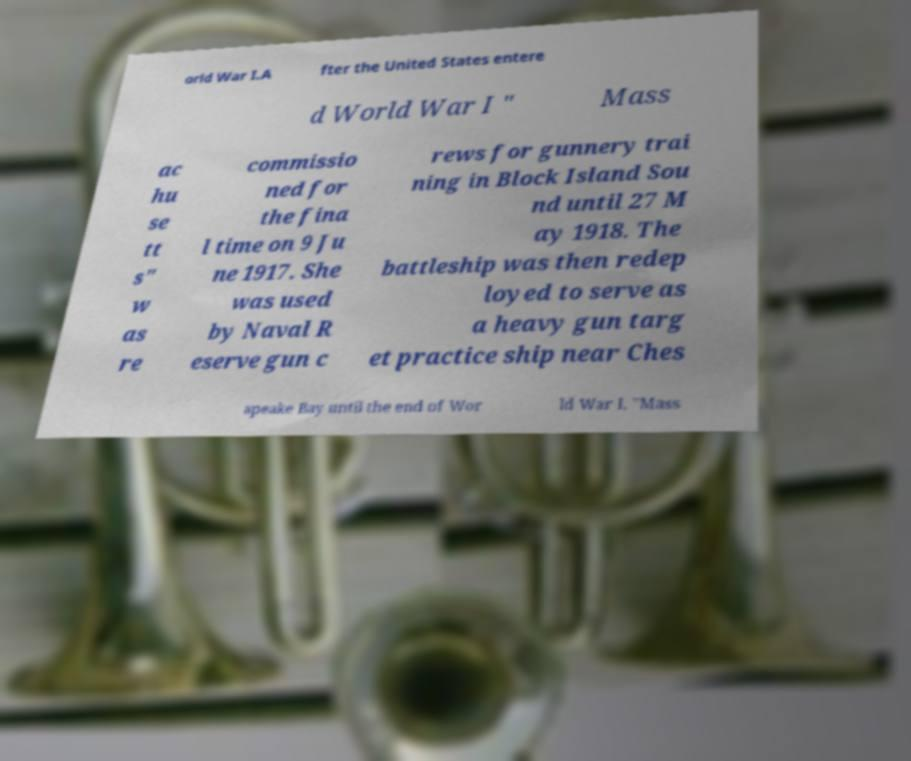Could you assist in decoding the text presented in this image and type it out clearly? orld War I.A fter the United States entere d World War I " Mass ac hu se tt s" w as re commissio ned for the fina l time on 9 Ju ne 1917. She was used by Naval R eserve gun c rews for gunnery trai ning in Block Island Sou nd until 27 M ay 1918. The battleship was then redep loyed to serve as a heavy gun targ et practice ship near Ches apeake Bay until the end of Wor ld War I. "Mass 